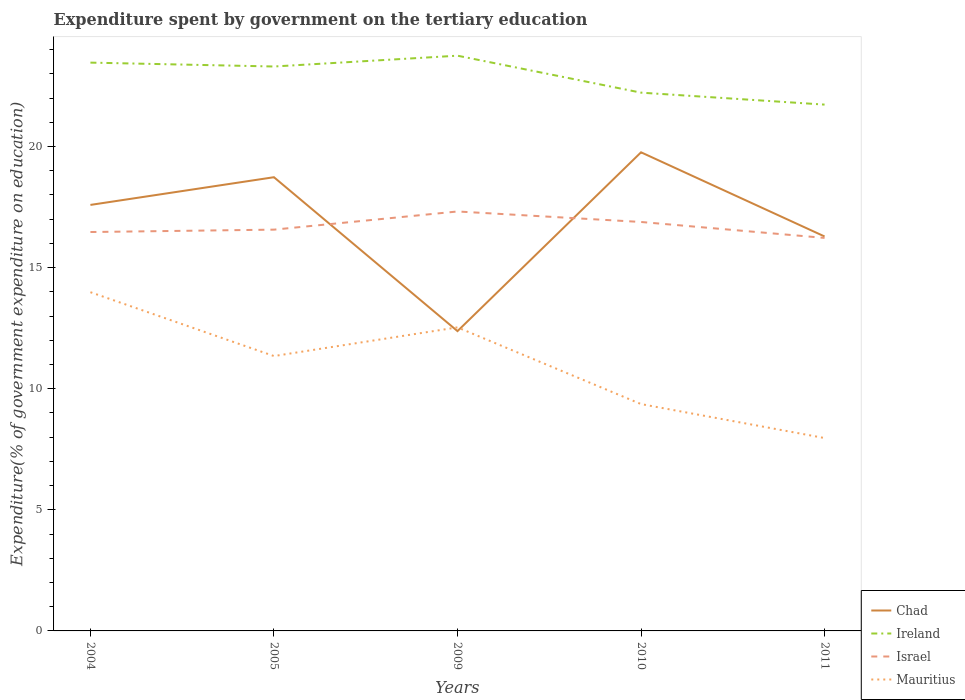Across all years, what is the maximum expenditure spent by government on the tertiary education in Mauritius?
Provide a succinct answer. 7.96. In which year was the expenditure spent by government on the tertiary education in Chad maximum?
Ensure brevity in your answer.  2009. What is the total expenditure spent by government on the tertiary education in Ireland in the graph?
Provide a succinct answer. 0.49. What is the difference between the highest and the second highest expenditure spent by government on the tertiary education in Mauritius?
Provide a succinct answer. 6.02. How many lines are there?
Make the answer very short. 4. How many years are there in the graph?
Give a very brief answer. 5. How many legend labels are there?
Give a very brief answer. 4. How are the legend labels stacked?
Provide a succinct answer. Vertical. What is the title of the graph?
Offer a very short reply. Expenditure spent by government on the tertiary education. What is the label or title of the X-axis?
Your answer should be very brief. Years. What is the label or title of the Y-axis?
Provide a short and direct response. Expenditure(% of government expenditure on education). What is the Expenditure(% of government expenditure on education) of Chad in 2004?
Your answer should be compact. 17.59. What is the Expenditure(% of government expenditure on education) in Ireland in 2004?
Offer a very short reply. 23.46. What is the Expenditure(% of government expenditure on education) in Israel in 2004?
Provide a succinct answer. 16.47. What is the Expenditure(% of government expenditure on education) of Mauritius in 2004?
Provide a short and direct response. 13.98. What is the Expenditure(% of government expenditure on education) of Chad in 2005?
Offer a very short reply. 18.73. What is the Expenditure(% of government expenditure on education) of Ireland in 2005?
Provide a succinct answer. 23.3. What is the Expenditure(% of government expenditure on education) in Israel in 2005?
Give a very brief answer. 16.57. What is the Expenditure(% of government expenditure on education) in Mauritius in 2005?
Offer a very short reply. 11.35. What is the Expenditure(% of government expenditure on education) of Chad in 2009?
Provide a succinct answer. 12.38. What is the Expenditure(% of government expenditure on education) in Ireland in 2009?
Make the answer very short. 23.75. What is the Expenditure(% of government expenditure on education) of Israel in 2009?
Ensure brevity in your answer.  17.32. What is the Expenditure(% of government expenditure on education) in Mauritius in 2009?
Ensure brevity in your answer.  12.53. What is the Expenditure(% of government expenditure on education) of Chad in 2010?
Your answer should be very brief. 19.76. What is the Expenditure(% of government expenditure on education) of Ireland in 2010?
Your answer should be very brief. 22.22. What is the Expenditure(% of government expenditure on education) in Israel in 2010?
Ensure brevity in your answer.  16.88. What is the Expenditure(% of government expenditure on education) of Mauritius in 2010?
Ensure brevity in your answer.  9.36. What is the Expenditure(% of government expenditure on education) in Chad in 2011?
Provide a short and direct response. 16.28. What is the Expenditure(% of government expenditure on education) of Ireland in 2011?
Keep it short and to the point. 21.73. What is the Expenditure(% of government expenditure on education) of Israel in 2011?
Your response must be concise. 16.22. What is the Expenditure(% of government expenditure on education) in Mauritius in 2011?
Provide a short and direct response. 7.96. Across all years, what is the maximum Expenditure(% of government expenditure on education) in Chad?
Provide a succinct answer. 19.76. Across all years, what is the maximum Expenditure(% of government expenditure on education) of Ireland?
Provide a short and direct response. 23.75. Across all years, what is the maximum Expenditure(% of government expenditure on education) in Israel?
Your answer should be very brief. 17.32. Across all years, what is the maximum Expenditure(% of government expenditure on education) in Mauritius?
Provide a succinct answer. 13.98. Across all years, what is the minimum Expenditure(% of government expenditure on education) in Chad?
Ensure brevity in your answer.  12.38. Across all years, what is the minimum Expenditure(% of government expenditure on education) of Ireland?
Ensure brevity in your answer.  21.73. Across all years, what is the minimum Expenditure(% of government expenditure on education) of Israel?
Your response must be concise. 16.22. Across all years, what is the minimum Expenditure(% of government expenditure on education) of Mauritius?
Ensure brevity in your answer.  7.96. What is the total Expenditure(% of government expenditure on education) in Chad in the graph?
Your answer should be compact. 84.74. What is the total Expenditure(% of government expenditure on education) in Ireland in the graph?
Offer a very short reply. 114.46. What is the total Expenditure(% of government expenditure on education) of Israel in the graph?
Provide a short and direct response. 83.46. What is the total Expenditure(% of government expenditure on education) in Mauritius in the graph?
Make the answer very short. 55.19. What is the difference between the Expenditure(% of government expenditure on education) of Chad in 2004 and that in 2005?
Your answer should be very brief. -1.14. What is the difference between the Expenditure(% of government expenditure on education) in Ireland in 2004 and that in 2005?
Ensure brevity in your answer.  0.16. What is the difference between the Expenditure(% of government expenditure on education) in Israel in 2004 and that in 2005?
Your answer should be very brief. -0.1. What is the difference between the Expenditure(% of government expenditure on education) in Mauritius in 2004 and that in 2005?
Your answer should be compact. 2.64. What is the difference between the Expenditure(% of government expenditure on education) of Chad in 2004 and that in 2009?
Provide a succinct answer. 5.21. What is the difference between the Expenditure(% of government expenditure on education) of Ireland in 2004 and that in 2009?
Ensure brevity in your answer.  -0.29. What is the difference between the Expenditure(% of government expenditure on education) in Israel in 2004 and that in 2009?
Offer a terse response. -0.85. What is the difference between the Expenditure(% of government expenditure on education) of Mauritius in 2004 and that in 2009?
Your response must be concise. 1.45. What is the difference between the Expenditure(% of government expenditure on education) in Chad in 2004 and that in 2010?
Provide a succinct answer. -2.17. What is the difference between the Expenditure(% of government expenditure on education) in Ireland in 2004 and that in 2010?
Offer a very short reply. 1.24. What is the difference between the Expenditure(% of government expenditure on education) in Israel in 2004 and that in 2010?
Your answer should be very brief. -0.41. What is the difference between the Expenditure(% of government expenditure on education) in Mauritius in 2004 and that in 2010?
Provide a succinct answer. 4.62. What is the difference between the Expenditure(% of government expenditure on education) in Chad in 2004 and that in 2011?
Your response must be concise. 1.3. What is the difference between the Expenditure(% of government expenditure on education) in Ireland in 2004 and that in 2011?
Your answer should be compact. 1.73. What is the difference between the Expenditure(% of government expenditure on education) of Israel in 2004 and that in 2011?
Give a very brief answer. 0.24. What is the difference between the Expenditure(% of government expenditure on education) in Mauritius in 2004 and that in 2011?
Your response must be concise. 6.02. What is the difference between the Expenditure(% of government expenditure on education) in Chad in 2005 and that in 2009?
Provide a succinct answer. 6.35. What is the difference between the Expenditure(% of government expenditure on education) in Ireland in 2005 and that in 2009?
Keep it short and to the point. -0.45. What is the difference between the Expenditure(% of government expenditure on education) of Israel in 2005 and that in 2009?
Give a very brief answer. -0.75. What is the difference between the Expenditure(% of government expenditure on education) in Mauritius in 2005 and that in 2009?
Offer a very short reply. -1.18. What is the difference between the Expenditure(% of government expenditure on education) in Chad in 2005 and that in 2010?
Give a very brief answer. -1.03. What is the difference between the Expenditure(% of government expenditure on education) in Ireland in 2005 and that in 2010?
Offer a terse response. 1.08. What is the difference between the Expenditure(% of government expenditure on education) in Israel in 2005 and that in 2010?
Make the answer very short. -0.32. What is the difference between the Expenditure(% of government expenditure on education) in Mauritius in 2005 and that in 2010?
Keep it short and to the point. 1.98. What is the difference between the Expenditure(% of government expenditure on education) in Chad in 2005 and that in 2011?
Keep it short and to the point. 2.45. What is the difference between the Expenditure(% of government expenditure on education) in Ireland in 2005 and that in 2011?
Offer a very short reply. 1.57. What is the difference between the Expenditure(% of government expenditure on education) of Israel in 2005 and that in 2011?
Your answer should be compact. 0.34. What is the difference between the Expenditure(% of government expenditure on education) of Mauritius in 2005 and that in 2011?
Make the answer very short. 3.38. What is the difference between the Expenditure(% of government expenditure on education) of Chad in 2009 and that in 2010?
Ensure brevity in your answer.  -7.38. What is the difference between the Expenditure(% of government expenditure on education) in Ireland in 2009 and that in 2010?
Your response must be concise. 1.53. What is the difference between the Expenditure(% of government expenditure on education) in Israel in 2009 and that in 2010?
Give a very brief answer. 0.43. What is the difference between the Expenditure(% of government expenditure on education) in Mauritius in 2009 and that in 2010?
Ensure brevity in your answer.  3.17. What is the difference between the Expenditure(% of government expenditure on education) in Chad in 2009 and that in 2011?
Give a very brief answer. -3.91. What is the difference between the Expenditure(% of government expenditure on education) in Ireland in 2009 and that in 2011?
Your response must be concise. 2.02. What is the difference between the Expenditure(% of government expenditure on education) of Israel in 2009 and that in 2011?
Offer a very short reply. 1.09. What is the difference between the Expenditure(% of government expenditure on education) in Mauritius in 2009 and that in 2011?
Keep it short and to the point. 4.57. What is the difference between the Expenditure(% of government expenditure on education) of Chad in 2010 and that in 2011?
Provide a short and direct response. 3.47. What is the difference between the Expenditure(% of government expenditure on education) in Ireland in 2010 and that in 2011?
Your answer should be compact. 0.49. What is the difference between the Expenditure(% of government expenditure on education) of Israel in 2010 and that in 2011?
Offer a very short reply. 0.66. What is the difference between the Expenditure(% of government expenditure on education) of Mauritius in 2010 and that in 2011?
Ensure brevity in your answer.  1.4. What is the difference between the Expenditure(% of government expenditure on education) in Chad in 2004 and the Expenditure(% of government expenditure on education) in Ireland in 2005?
Provide a short and direct response. -5.71. What is the difference between the Expenditure(% of government expenditure on education) in Chad in 2004 and the Expenditure(% of government expenditure on education) in Israel in 2005?
Make the answer very short. 1.02. What is the difference between the Expenditure(% of government expenditure on education) of Chad in 2004 and the Expenditure(% of government expenditure on education) of Mauritius in 2005?
Give a very brief answer. 6.24. What is the difference between the Expenditure(% of government expenditure on education) of Ireland in 2004 and the Expenditure(% of government expenditure on education) of Israel in 2005?
Your response must be concise. 6.9. What is the difference between the Expenditure(% of government expenditure on education) in Ireland in 2004 and the Expenditure(% of government expenditure on education) in Mauritius in 2005?
Your answer should be compact. 12.11. What is the difference between the Expenditure(% of government expenditure on education) in Israel in 2004 and the Expenditure(% of government expenditure on education) in Mauritius in 2005?
Provide a short and direct response. 5.12. What is the difference between the Expenditure(% of government expenditure on education) of Chad in 2004 and the Expenditure(% of government expenditure on education) of Ireland in 2009?
Offer a terse response. -6.16. What is the difference between the Expenditure(% of government expenditure on education) in Chad in 2004 and the Expenditure(% of government expenditure on education) in Israel in 2009?
Keep it short and to the point. 0.27. What is the difference between the Expenditure(% of government expenditure on education) in Chad in 2004 and the Expenditure(% of government expenditure on education) in Mauritius in 2009?
Your answer should be compact. 5.06. What is the difference between the Expenditure(% of government expenditure on education) of Ireland in 2004 and the Expenditure(% of government expenditure on education) of Israel in 2009?
Make the answer very short. 6.15. What is the difference between the Expenditure(% of government expenditure on education) of Ireland in 2004 and the Expenditure(% of government expenditure on education) of Mauritius in 2009?
Provide a succinct answer. 10.93. What is the difference between the Expenditure(% of government expenditure on education) in Israel in 2004 and the Expenditure(% of government expenditure on education) in Mauritius in 2009?
Your answer should be compact. 3.94. What is the difference between the Expenditure(% of government expenditure on education) in Chad in 2004 and the Expenditure(% of government expenditure on education) in Ireland in 2010?
Offer a terse response. -4.63. What is the difference between the Expenditure(% of government expenditure on education) of Chad in 2004 and the Expenditure(% of government expenditure on education) of Israel in 2010?
Keep it short and to the point. 0.7. What is the difference between the Expenditure(% of government expenditure on education) of Chad in 2004 and the Expenditure(% of government expenditure on education) of Mauritius in 2010?
Your answer should be very brief. 8.22. What is the difference between the Expenditure(% of government expenditure on education) in Ireland in 2004 and the Expenditure(% of government expenditure on education) in Israel in 2010?
Your answer should be very brief. 6.58. What is the difference between the Expenditure(% of government expenditure on education) in Ireland in 2004 and the Expenditure(% of government expenditure on education) in Mauritius in 2010?
Provide a short and direct response. 14.1. What is the difference between the Expenditure(% of government expenditure on education) in Israel in 2004 and the Expenditure(% of government expenditure on education) in Mauritius in 2010?
Make the answer very short. 7.1. What is the difference between the Expenditure(% of government expenditure on education) in Chad in 2004 and the Expenditure(% of government expenditure on education) in Ireland in 2011?
Your answer should be very brief. -4.14. What is the difference between the Expenditure(% of government expenditure on education) of Chad in 2004 and the Expenditure(% of government expenditure on education) of Israel in 2011?
Provide a short and direct response. 1.36. What is the difference between the Expenditure(% of government expenditure on education) of Chad in 2004 and the Expenditure(% of government expenditure on education) of Mauritius in 2011?
Provide a succinct answer. 9.62. What is the difference between the Expenditure(% of government expenditure on education) of Ireland in 2004 and the Expenditure(% of government expenditure on education) of Israel in 2011?
Make the answer very short. 7.24. What is the difference between the Expenditure(% of government expenditure on education) in Ireland in 2004 and the Expenditure(% of government expenditure on education) in Mauritius in 2011?
Keep it short and to the point. 15.5. What is the difference between the Expenditure(% of government expenditure on education) of Israel in 2004 and the Expenditure(% of government expenditure on education) of Mauritius in 2011?
Offer a terse response. 8.5. What is the difference between the Expenditure(% of government expenditure on education) in Chad in 2005 and the Expenditure(% of government expenditure on education) in Ireland in 2009?
Keep it short and to the point. -5.02. What is the difference between the Expenditure(% of government expenditure on education) of Chad in 2005 and the Expenditure(% of government expenditure on education) of Israel in 2009?
Your answer should be compact. 1.41. What is the difference between the Expenditure(% of government expenditure on education) of Chad in 2005 and the Expenditure(% of government expenditure on education) of Mauritius in 2009?
Your answer should be compact. 6.2. What is the difference between the Expenditure(% of government expenditure on education) in Ireland in 2005 and the Expenditure(% of government expenditure on education) in Israel in 2009?
Give a very brief answer. 5.99. What is the difference between the Expenditure(% of government expenditure on education) in Ireland in 2005 and the Expenditure(% of government expenditure on education) in Mauritius in 2009?
Your response must be concise. 10.77. What is the difference between the Expenditure(% of government expenditure on education) of Israel in 2005 and the Expenditure(% of government expenditure on education) of Mauritius in 2009?
Your answer should be very brief. 4.03. What is the difference between the Expenditure(% of government expenditure on education) of Chad in 2005 and the Expenditure(% of government expenditure on education) of Ireland in 2010?
Your answer should be compact. -3.49. What is the difference between the Expenditure(% of government expenditure on education) of Chad in 2005 and the Expenditure(% of government expenditure on education) of Israel in 2010?
Give a very brief answer. 1.85. What is the difference between the Expenditure(% of government expenditure on education) of Chad in 2005 and the Expenditure(% of government expenditure on education) of Mauritius in 2010?
Offer a very short reply. 9.37. What is the difference between the Expenditure(% of government expenditure on education) of Ireland in 2005 and the Expenditure(% of government expenditure on education) of Israel in 2010?
Provide a succinct answer. 6.42. What is the difference between the Expenditure(% of government expenditure on education) in Ireland in 2005 and the Expenditure(% of government expenditure on education) in Mauritius in 2010?
Your answer should be very brief. 13.94. What is the difference between the Expenditure(% of government expenditure on education) in Israel in 2005 and the Expenditure(% of government expenditure on education) in Mauritius in 2010?
Give a very brief answer. 7.2. What is the difference between the Expenditure(% of government expenditure on education) in Chad in 2005 and the Expenditure(% of government expenditure on education) in Ireland in 2011?
Provide a succinct answer. -3. What is the difference between the Expenditure(% of government expenditure on education) of Chad in 2005 and the Expenditure(% of government expenditure on education) of Israel in 2011?
Offer a terse response. 2.51. What is the difference between the Expenditure(% of government expenditure on education) of Chad in 2005 and the Expenditure(% of government expenditure on education) of Mauritius in 2011?
Give a very brief answer. 10.77. What is the difference between the Expenditure(% of government expenditure on education) of Ireland in 2005 and the Expenditure(% of government expenditure on education) of Israel in 2011?
Your response must be concise. 7.08. What is the difference between the Expenditure(% of government expenditure on education) in Ireland in 2005 and the Expenditure(% of government expenditure on education) in Mauritius in 2011?
Ensure brevity in your answer.  15.34. What is the difference between the Expenditure(% of government expenditure on education) of Israel in 2005 and the Expenditure(% of government expenditure on education) of Mauritius in 2011?
Your answer should be very brief. 8.6. What is the difference between the Expenditure(% of government expenditure on education) in Chad in 2009 and the Expenditure(% of government expenditure on education) in Ireland in 2010?
Offer a very short reply. -9.84. What is the difference between the Expenditure(% of government expenditure on education) in Chad in 2009 and the Expenditure(% of government expenditure on education) in Israel in 2010?
Your answer should be very brief. -4.51. What is the difference between the Expenditure(% of government expenditure on education) of Chad in 2009 and the Expenditure(% of government expenditure on education) of Mauritius in 2010?
Your answer should be very brief. 3.01. What is the difference between the Expenditure(% of government expenditure on education) of Ireland in 2009 and the Expenditure(% of government expenditure on education) of Israel in 2010?
Your answer should be very brief. 6.86. What is the difference between the Expenditure(% of government expenditure on education) in Ireland in 2009 and the Expenditure(% of government expenditure on education) in Mauritius in 2010?
Provide a short and direct response. 14.38. What is the difference between the Expenditure(% of government expenditure on education) in Israel in 2009 and the Expenditure(% of government expenditure on education) in Mauritius in 2010?
Make the answer very short. 7.95. What is the difference between the Expenditure(% of government expenditure on education) in Chad in 2009 and the Expenditure(% of government expenditure on education) in Ireland in 2011?
Provide a succinct answer. -9.35. What is the difference between the Expenditure(% of government expenditure on education) of Chad in 2009 and the Expenditure(% of government expenditure on education) of Israel in 2011?
Make the answer very short. -3.85. What is the difference between the Expenditure(% of government expenditure on education) of Chad in 2009 and the Expenditure(% of government expenditure on education) of Mauritius in 2011?
Make the answer very short. 4.41. What is the difference between the Expenditure(% of government expenditure on education) in Ireland in 2009 and the Expenditure(% of government expenditure on education) in Israel in 2011?
Provide a succinct answer. 7.52. What is the difference between the Expenditure(% of government expenditure on education) of Ireland in 2009 and the Expenditure(% of government expenditure on education) of Mauritius in 2011?
Your answer should be very brief. 15.78. What is the difference between the Expenditure(% of government expenditure on education) of Israel in 2009 and the Expenditure(% of government expenditure on education) of Mauritius in 2011?
Offer a terse response. 9.35. What is the difference between the Expenditure(% of government expenditure on education) of Chad in 2010 and the Expenditure(% of government expenditure on education) of Ireland in 2011?
Keep it short and to the point. -1.97. What is the difference between the Expenditure(% of government expenditure on education) of Chad in 2010 and the Expenditure(% of government expenditure on education) of Israel in 2011?
Provide a succinct answer. 3.53. What is the difference between the Expenditure(% of government expenditure on education) of Chad in 2010 and the Expenditure(% of government expenditure on education) of Mauritius in 2011?
Keep it short and to the point. 11.8. What is the difference between the Expenditure(% of government expenditure on education) of Ireland in 2010 and the Expenditure(% of government expenditure on education) of Israel in 2011?
Provide a short and direct response. 6. What is the difference between the Expenditure(% of government expenditure on education) in Ireland in 2010 and the Expenditure(% of government expenditure on education) in Mauritius in 2011?
Offer a very short reply. 14.26. What is the difference between the Expenditure(% of government expenditure on education) of Israel in 2010 and the Expenditure(% of government expenditure on education) of Mauritius in 2011?
Make the answer very short. 8.92. What is the average Expenditure(% of government expenditure on education) in Chad per year?
Your answer should be compact. 16.95. What is the average Expenditure(% of government expenditure on education) of Ireland per year?
Offer a terse response. 22.89. What is the average Expenditure(% of government expenditure on education) in Israel per year?
Your answer should be very brief. 16.69. What is the average Expenditure(% of government expenditure on education) in Mauritius per year?
Provide a short and direct response. 11.04. In the year 2004, what is the difference between the Expenditure(% of government expenditure on education) in Chad and Expenditure(% of government expenditure on education) in Ireland?
Your answer should be very brief. -5.87. In the year 2004, what is the difference between the Expenditure(% of government expenditure on education) in Chad and Expenditure(% of government expenditure on education) in Israel?
Your answer should be very brief. 1.12. In the year 2004, what is the difference between the Expenditure(% of government expenditure on education) in Chad and Expenditure(% of government expenditure on education) in Mauritius?
Keep it short and to the point. 3.6. In the year 2004, what is the difference between the Expenditure(% of government expenditure on education) of Ireland and Expenditure(% of government expenditure on education) of Israel?
Your answer should be compact. 6.99. In the year 2004, what is the difference between the Expenditure(% of government expenditure on education) in Ireland and Expenditure(% of government expenditure on education) in Mauritius?
Ensure brevity in your answer.  9.48. In the year 2004, what is the difference between the Expenditure(% of government expenditure on education) of Israel and Expenditure(% of government expenditure on education) of Mauritius?
Make the answer very short. 2.48. In the year 2005, what is the difference between the Expenditure(% of government expenditure on education) of Chad and Expenditure(% of government expenditure on education) of Ireland?
Your answer should be compact. -4.57. In the year 2005, what is the difference between the Expenditure(% of government expenditure on education) in Chad and Expenditure(% of government expenditure on education) in Israel?
Make the answer very short. 2.16. In the year 2005, what is the difference between the Expenditure(% of government expenditure on education) in Chad and Expenditure(% of government expenditure on education) in Mauritius?
Ensure brevity in your answer.  7.38. In the year 2005, what is the difference between the Expenditure(% of government expenditure on education) of Ireland and Expenditure(% of government expenditure on education) of Israel?
Give a very brief answer. 6.74. In the year 2005, what is the difference between the Expenditure(% of government expenditure on education) of Ireland and Expenditure(% of government expenditure on education) of Mauritius?
Provide a succinct answer. 11.95. In the year 2005, what is the difference between the Expenditure(% of government expenditure on education) in Israel and Expenditure(% of government expenditure on education) in Mauritius?
Provide a short and direct response. 5.22. In the year 2009, what is the difference between the Expenditure(% of government expenditure on education) of Chad and Expenditure(% of government expenditure on education) of Ireland?
Provide a short and direct response. -11.37. In the year 2009, what is the difference between the Expenditure(% of government expenditure on education) in Chad and Expenditure(% of government expenditure on education) in Israel?
Provide a short and direct response. -4.94. In the year 2009, what is the difference between the Expenditure(% of government expenditure on education) of Chad and Expenditure(% of government expenditure on education) of Mauritius?
Offer a terse response. -0.15. In the year 2009, what is the difference between the Expenditure(% of government expenditure on education) in Ireland and Expenditure(% of government expenditure on education) in Israel?
Your response must be concise. 6.43. In the year 2009, what is the difference between the Expenditure(% of government expenditure on education) in Ireland and Expenditure(% of government expenditure on education) in Mauritius?
Make the answer very short. 11.22. In the year 2009, what is the difference between the Expenditure(% of government expenditure on education) in Israel and Expenditure(% of government expenditure on education) in Mauritius?
Make the answer very short. 4.78. In the year 2010, what is the difference between the Expenditure(% of government expenditure on education) in Chad and Expenditure(% of government expenditure on education) in Ireland?
Provide a succinct answer. -2.46. In the year 2010, what is the difference between the Expenditure(% of government expenditure on education) of Chad and Expenditure(% of government expenditure on education) of Israel?
Give a very brief answer. 2.88. In the year 2010, what is the difference between the Expenditure(% of government expenditure on education) of Chad and Expenditure(% of government expenditure on education) of Mauritius?
Offer a terse response. 10.39. In the year 2010, what is the difference between the Expenditure(% of government expenditure on education) of Ireland and Expenditure(% of government expenditure on education) of Israel?
Your response must be concise. 5.34. In the year 2010, what is the difference between the Expenditure(% of government expenditure on education) in Ireland and Expenditure(% of government expenditure on education) in Mauritius?
Provide a succinct answer. 12.86. In the year 2010, what is the difference between the Expenditure(% of government expenditure on education) in Israel and Expenditure(% of government expenditure on education) in Mauritius?
Keep it short and to the point. 7.52. In the year 2011, what is the difference between the Expenditure(% of government expenditure on education) of Chad and Expenditure(% of government expenditure on education) of Ireland?
Ensure brevity in your answer.  -5.44. In the year 2011, what is the difference between the Expenditure(% of government expenditure on education) of Chad and Expenditure(% of government expenditure on education) of Israel?
Give a very brief answer. 0.06. In the year 2011, what is the difference between the Expenditure(% of government expenditure on education) in Chad and Expenditure(% of government expenditure on education) in Mauritius?
Provide a short and direct response. 8.32. In the year 2011, what is the difference between the Expenditure(% of government expenditure on education) in Ireland and Expenditure(% of government expenditure on education) in Israel?
Provide a short and direct response. 5.5. In the year 2011, what is the difference between the Expenditure(% of government expenditure on education) in Ireland and Expenditure(% of government expenditure on education) in Mauritius?
Provide a succinct answer. 13.76. In the year 2011, what is the difference between the Expenditure(% of government expenditure on education) in Israel and Expenditure(% of government expenditure on education) in Mauritius?
Your answer should be compact. 8.26. What is the ratio of the Expenditure(% of government expenditure on education) of Chad in 2004 to that in 2005?
Ensure brevity in your answer.  0.94. What is the ratio of the Expenditure(% of government expenditure on education) of Israel in 2004 to that in 2005?
Your answer should be very brief. 0.99. What is the ratio of the Expenditure(% of government expenditure on education) in Mauritius in 2004 to that in 2005?
Provide a short and direct response. 1.23. What is the ratio of the Expenditure(% of government expenditure on education) of Chad in 2004 to that in 2009?
Your answer should be very brief. 1.42. What is the ratio of the Expenditure(% of government expenditure on education) in Ireland in 2004 to that in 2009?
Keep it short and to the point. 0.99. What is the ratio of the Expenditure(% of government expenditure on education) in Israel in 2004 to that in 2009?
Your answer should be very brief. 0.95. What is the ratio of the Expenditure(% of government expenditure on education) of Mauritius in 2004 to that in 2009?
Your answer should be very brief. 1.12. What is the ratio of the Expenditure(% of government expenditure on education) in Chad in 2004 to that in 2010?
Provide a short and direct response. 0.89. What is the ratio of the Expenditure(% of government expenditure on education) in Ireland in 2004 to that in 2010?
Keep it short and to the point. 1.06. What is the ratio of the Expenditure(% of government expenditure on education) in Israel in 2004 to that in 2010?
Make the answer very short. 0.98. What is the ratio of the Expenditure(% of government expenditure on education) of Mauritius in 2004 to that in 2010?
Provide a short and direct response. 1.49. What is the ratio of the Expenditure(% of government expenditure on education) in Ireland in 2004 to that in 2011?
Make the answer very short. 1.08. What is the ratio of the Expenditure(% of government expenditure on education) of Mauritius in 2004 to that in 2011?
Ensure brevity in your answer.  1.76. What is the ratio of the Expenditure(% of government expenditure on education) in Chad in 2005 to that in 2009?
Your response must be concise. 1.51. What is the ratio of the Expenditure(% of government expenditure on education) of Ireland in 2005 to that in 2009?
Provide a succinct answer. 0.98. What is the ratio of the Expenditure(% of government expenditure on education) in Israel in 2005 to that in 2009?
Your response must be concise. 0.96. What is the ratio of the Expenditure(% of government expenditure on education) in Mauritius in 2005 to that in 2009?
Provide a succinct answer. 0.91. What is the ratio of the Expenditure(% of government expenditure on education) of Chad in 2005 to that in 2010?
Provide a succinct answer. 0.95. What is the ratio of the Expenditure(% of government expenditure on education) in Ireland in 2005 to that in 2010?
Give a very brief answer. 1.05. What is the ratio of the Expenditure(% of government expenditure on education) in Israel in 2005 to that in 2010?
Offer a very short reply. 0.98. What is the ratio of the Expenditure(% of government expenditure on education) in Mauritius in 2005 to that in 2010?
Ensure brevity in your answer.  1.21. What is the ratio of the Expenditure(% of government expenditure on education) in Chad in 2005 to that in 2011?
Give a very brief answer. 1.15. What is the ratio of the Expenditure(% of government expenditure on education) in Ireland in 2005 to that in 2011?
Provide a short and direct response. 1.07. What is the ratio of the Expenditure(% of government expenditure on education) in Mauritius in 2005 to that in 2011?
Make the answer very short. 1.43. What is the ratio of the Expenditure(% of government expenditure on education) of Chad in 2009 to that in 2010?
Offer a very short reply. 0.63. What is the ratio of the Expenditure(% of government expenditure on education) in Ireland in 2009 to that in 2010?
Make the answer very short. 1.07. What is the ratio of the Expenditure(% of government expenditure on education) of Israel in 2009 to that in 2010?
Your answer should be compact. 1.03. What is the ratio of the Expenditure(% of government expenditure on education) of Mauritius in 2009 to that in 2010?
Your answer should be compact. 1.34. What is the ratio of the Expenditure(% of government expenditure on education) in Chad in 2009 to that in 2011?
Provide a short and direct response. 0.76. What is the ratio of the Expenditure(% of government expenditure on education) in Ireland in 2009 to that in 2011?
Offer a very short reply. 1.09. What is the ratio of the Expenditure(% of government expenditure on education) in Israel in 2009 to that in 2011?
Make the answer very short. 1.07. What is the ratio of the Expenditure(% of government expenditure on education) of Mauritius in 2009 to that in 2011?
Your answer should be very brief. 1.57. What is the ratio of the Expenditure(% of government expenditure on education) of Chad in 2010 to that in 2011?
Give a very brief answer. 1.21. What is the ratio of the Expenditure(% of government expenditure on education) of Ireland in 2010 to that in 2011?
Offer a terse response. 1.02. What is the ratio of the Expenditure(% of government expenditure on education) of Israel in 2010 to that in 2011?
Make the answer very short. 1.04. What is the ratio of the Expenditure(% of government expenditure on education) of Mauritius in 2010 to that in 2011?
Make the answer very short. 1.18. What is the difference between the highest and the second highest Expenditure(% of government expenditure on education) in Chad?
Ensure brevity in your answer.  1.03. What is the difference between the highest and the second highest Expenditure(% of government expenditure on education) of Ireland?
Provide a succinct answer. 0.29. What is the difference between the highest and the second highest Expenditure(% of government expenditure on education) of Israel?
Your answer should be compact. 0.43. What is the difference between the highest and the second highest Expenditure(% of government expenditure on education) of Mauritius?
Your response must be concise. 1.45. What is the difference between the highest and the lowest Expenditure(% of government expenditure on education) in Chad?
Give a very brief answer. 7.38. What is the difference between the highest and the lowest Expenditure(% of government expenditure on education) of Ireland?
Your response must be concise. 2.02. What is the difference between the highest and the lowest Expenditure(% of government expenditure on education) of Israel?
Offer a terse response. 1.09. What is the difference between the highest and the lowest Expenditure(% of government expenditure on education) in Mauritius?
Offer a very short reply. 6.02. 